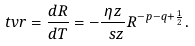<formula> <loc_0><loc_0><loc_500><loc_500>\ t v r = \frac { d R } { d T } = - \frac { \eta z } { \ s z } R ^ { - p - q + \frac { 1 } { 2 } } .</formula> 